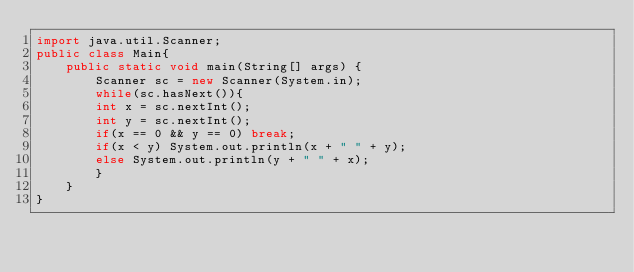<code> <loc_0><loc_0><loc_500><loc_500><_Java_>import java.util.Scanner;
public class Main{
    public static void main(String[] args) {
        Scanner sc = new Scanner(System.in);
        while(sc.hasNext()){
        int x = sc.nextInt();
        int y = sc.nextInt();
        if(x == 0 && y == 0) break;
        if(x < y) System.out.println(x + " " + y);
        else System.out.println(y + " " + x);
        }
    }
}
</code> 